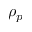<formula> <loc_0><loc_0><loc_500><loc_500>\rho _ { p }</formula> 